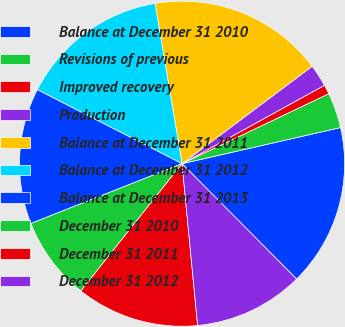Convert chart to OTSL. <chart><loc_0><loc_0><loc_500><loc_500><pie_chart><fcel>Balance at December 31 2010<fcel>Revisions of previous<fcel>Improved recovery<fcel>Production<fcel>Balance at December 31 2011<fcel>Balance at December 31 2012<fcel>Balance at December 31 2013<fcel>December 31 2010<fcel>December 31 2011<fcel>December 31 2012<nl><fcel>16.12%<fcel>3.52%<fcel>0.92%<fcel>2.22%<fcel>17.43%<fcel>14.82%<fcel>13.52%<fcel>8.31%<fcel>12.22%<fcel>10.92%<nl></chart> 